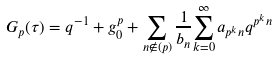Convert formula to latex. <formula><loc_0><loc_0><loc_500><loc_500>G _ { p } ( \tau ) = { q ^ { - 1 } + g ^ { p } _ { 0 } + \sum _ { n \notin { ( p ) } } \frac { 1 } { b _ { n } } { \sum _ { k = 0 } ^ { \infty } a _ { p ^ { k } n } q ^ { p ^ { k } n } } }</formula> 